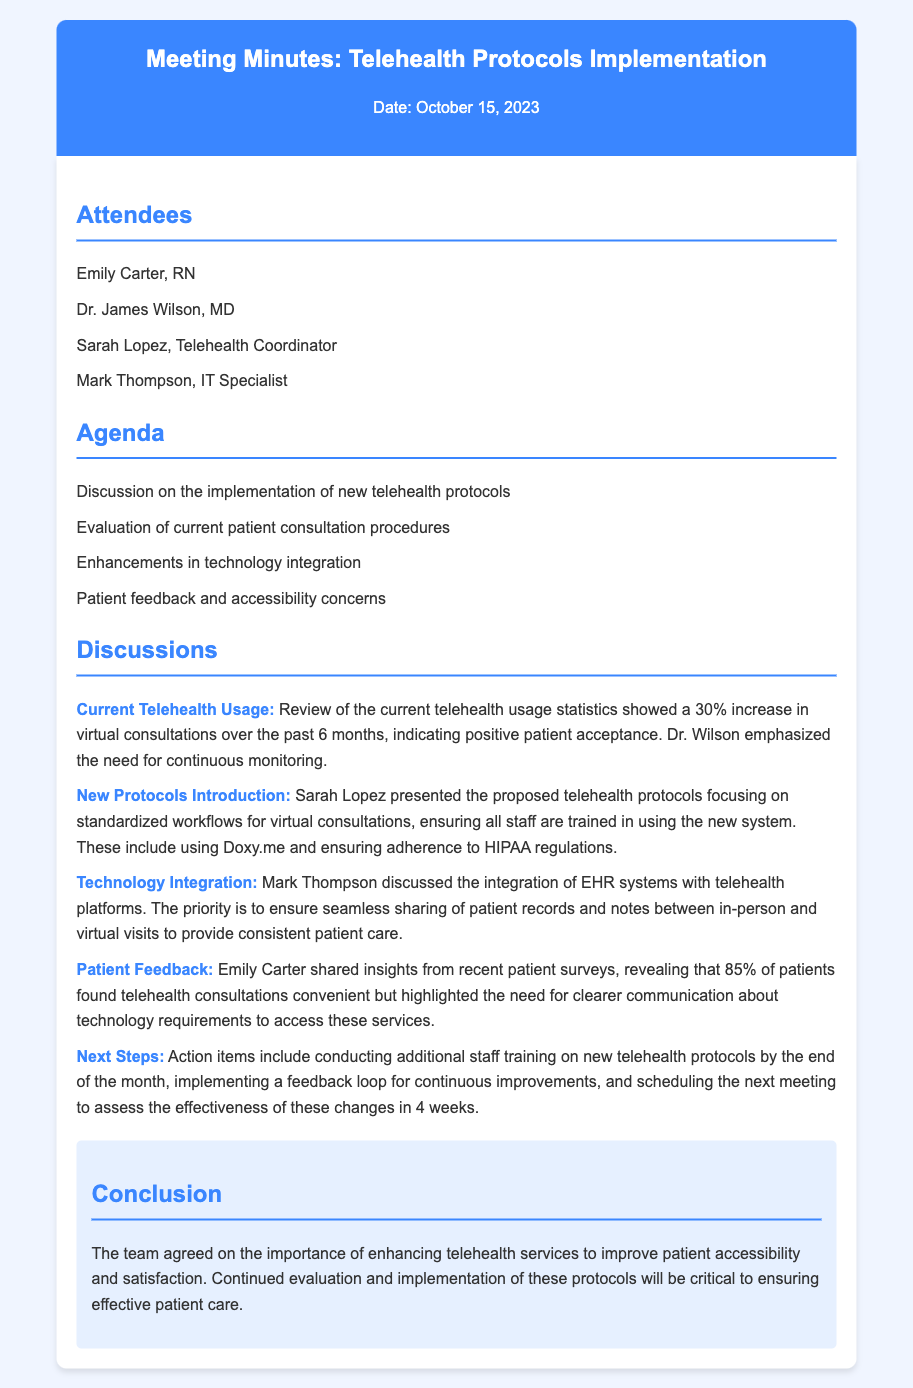What is the date of the meeting? The date of the meeting is mentioned at the top of the document.
Answer: October 15, 2023 Who presented the proposed telehealth protocols? The document states that Sarah Lopez presented the proposed telehealth protocols.
Answer: Sarah Lopez How much did virtual consultations increase over the past 6 months? Current telehealth usage statistics indicate an increase in virtual consultations.
Answer: 30% What percentage of patients found telehealth consultations convenient? Patient survey insights reveal a specific percentage regarding convenience.
Answer: 85% What platform was mentioned for virtual consultations? The document specifies a platform being used for telehealth consultations.
Answer: Doxy.me What is the priority for technology integration? Mark Thompson discusses the main goal for technology integration in telehealth.
Answer: Seamless sharing of patient records What action items are mentioned for staff training? The document outlines specific action items related to training staff on new protocols.
Answer: Conducting additional staff training How often will the effectiveness of the changes be assessed? The document mentions a timeframe for assessing effectiveness post-implementation.
Answer: In 4 weeks What is the main conclusion of the meeting? The conclusion summarizes the key agreement reached by the team during the discussion.
Answer: Improving patient accessibility and satisfaction 